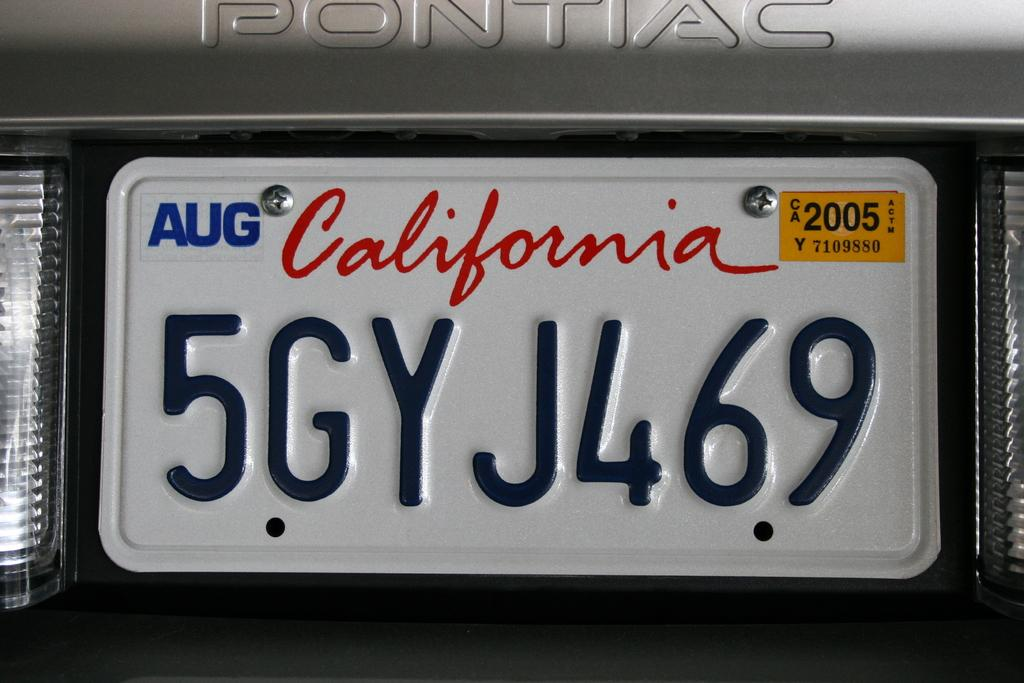What type of vehicle is in the image? There is a vehicle in the image, but the specific type is not mentioned in the facts. What is the position of the vehicle in the image? The vehicle's front is parked in the image. What can be seen on the vehicle in the image? The vehicle's lights are visible in the image. Is there any identification or labeling on the vehicle? Yes, there is a name plate in the image. Where might this image have been taken? The image is likely taken on a road, as suggested by the presence of a vehicle and a name plate. What type of mint is growing near the vehicle in the image? There is no mention of mint or any plants in the image, so it cannot be determined if mint is present. 